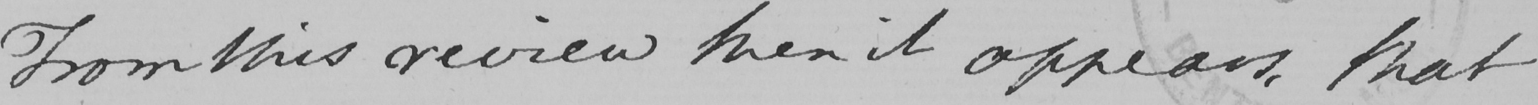Please provide the text content of this handwritten line. From this review then it appears, that 